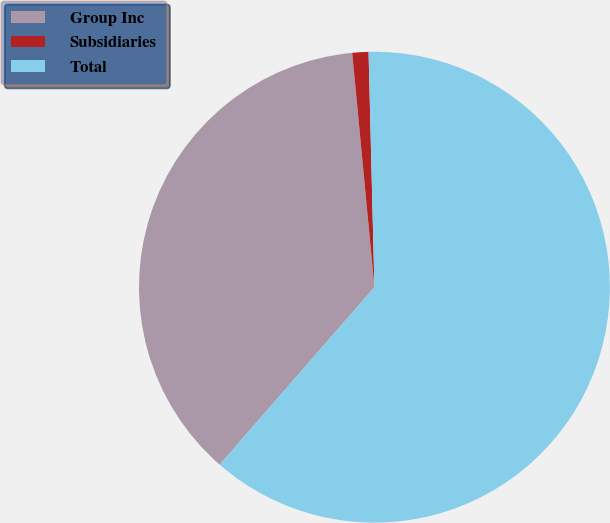<chart> <loc_0><loc_0><loc_500><loc_500><pie_chart><fcel>Group Inc<fcel>Subsidiaries<fcel>Total<nl><fcel>37.08%<fcel>1.11%<fcel>61.81%<nl></chart> 